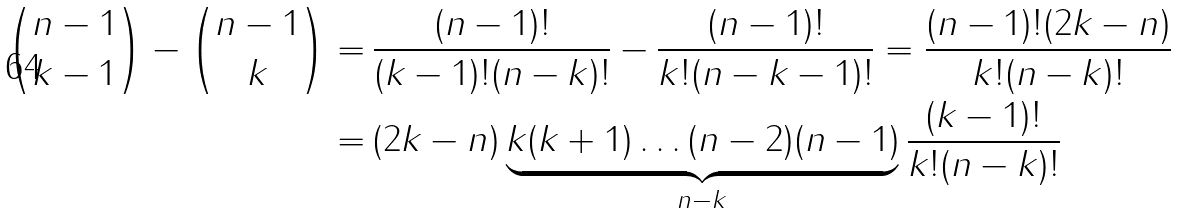<formula> <loc_0><loc_0><loc_500><loc_500>\binom { n - 1 } { k - 1 } - \binom { n - 1 } { k } = \, & \frac { ( n - 1 ) ! } { ( k - 1 ) ! ( n - k ) ! } - \frac { ( n - 1 ) ! } { k ! ( n - k - 1 ) ! } = \frac { ( n - 1 ) ! ( 2 k - n ) } { k ! ( n - k ) ! } \\ = \, & ( 2 k - n ) \underbrace { k ( k + 1 ) \dots ( n - 2 ) ( n - 1 ) } _ { n - k } \frac { ( k - 1 ) ! } { k ! ( n - k ) ! }</formula> 